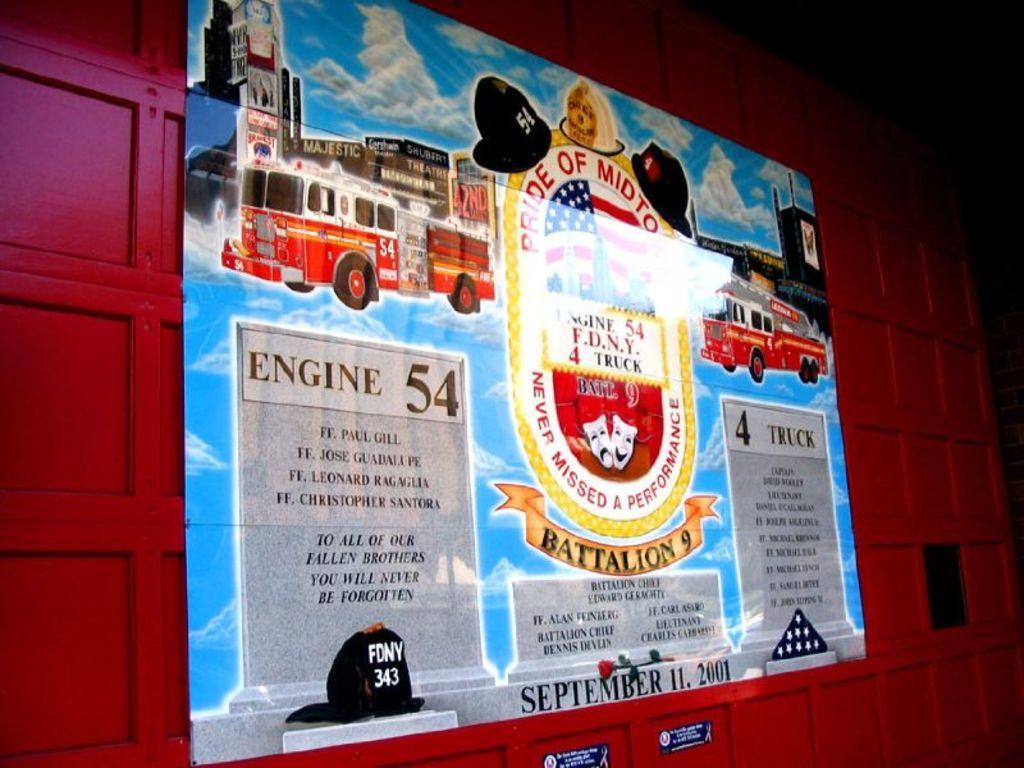Could you give a brief overview of what you see in this image? In this image I can see a poster on the wall. 